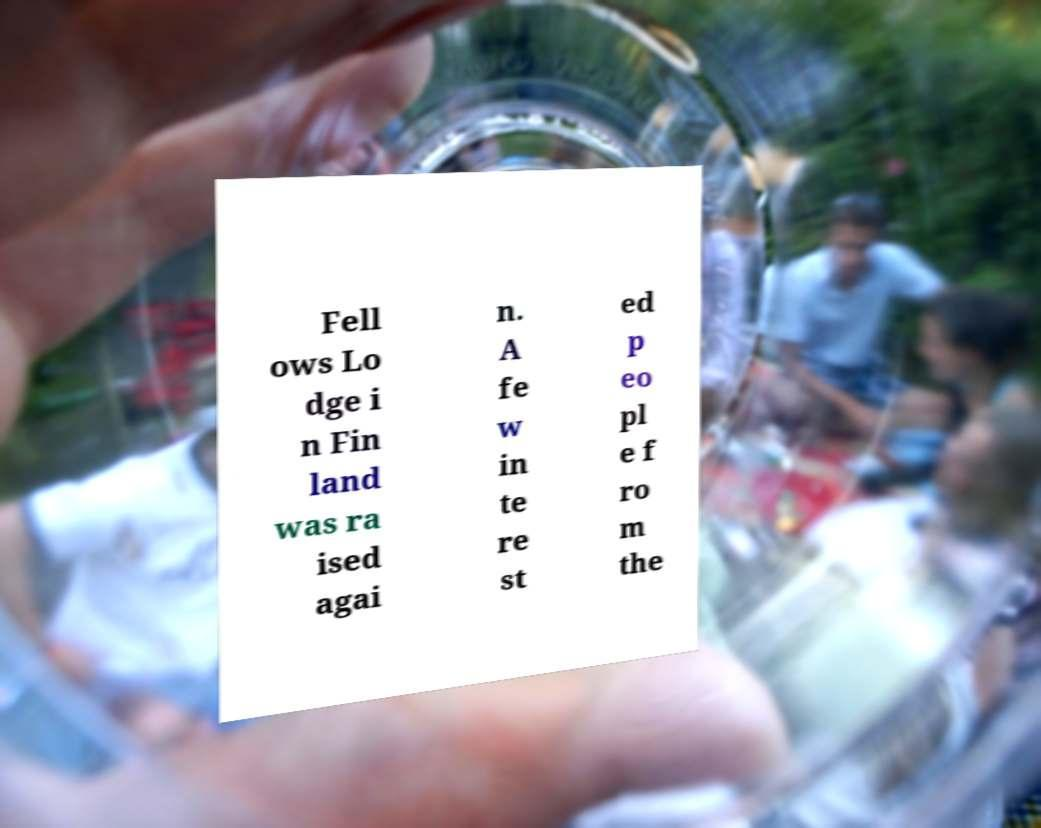Could you extract and type out the text from this image? Fell ows Lo dge i n Fin land was ra ised agai n. A fe w in te re st ed p eo pl e f ro m the 